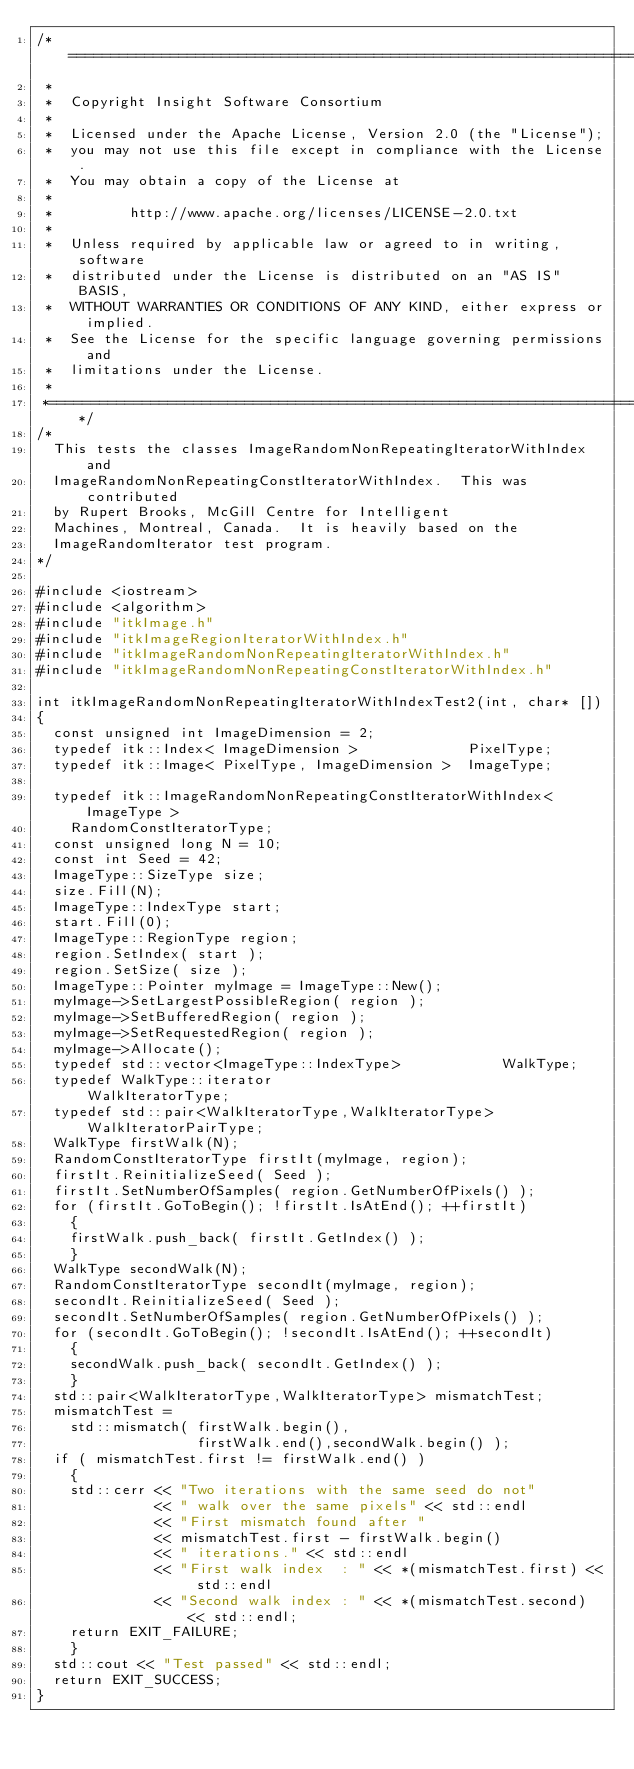<code> <loc_0><loc_0><loc_500><loc_500><_C++_>/*=========================================================================
 *
 *  Copyright Insight Software Consortium
 *
 *  Licensed under the Apache License, Version 2.0 (the "License");
 *  you may not use this file except in compliance with the License.
 *  You may obtain a copy of the License at
 *
 *         http://www.apache.org/licenses/LICENSE-2.0.txt
 *
 *  Unless required by applicable law or agreed to in writing, software
 *  distributed under the License is distributed on an "AS IS" BASIS,
 *  WITHOUT WARRANTIES OR CONDITIONS OF ANY KIND, either express or implied.
 *  See the License for the specific language governing permissions and
 *  limitations under the License.
 *
 *=========================================================================*/
/*
  This tests the classes ImageRandomNonRepeatingIteratorWithIndex and
  ImageRandomNonRepeatingConstIteratorWithIndex.  This was contributed
  by Rupert Brooks, McGill Centre for Intelligent
  Machines, Montreal, Canada.  It is heavily based on the
  ImageRandomIterator test program.
*/

#include <iostream>
#include <algorithm>
#include "itkImage.h"
#include "itkImageRegionIteratorWithIndex.h"
#include "itkImageRandomNonRepeatingIteratorWithIndex.h"
#include "itkImageRandomNonRepeatingConstIteratorWithIndex.h"

int itkImageRandomNonRepeatingIteratorWithIndexTest2(int, char* [])
{
  const unsigned int ImageDimension = 2;
  typedef itk::Index< ImageDimension >             PixelType;
  typedef itk::Image< PixelType, ImageDimension >  ImageType;

  typedef itk::ImageRandomNonRepeatingConstIteratorWithIndex< ImageType >
    RandomConstIteratorType;
  const unsigned long N = 10;
  const int Seed = 42;
  ImageType::SizeType size;
  size.Fill(N);
  ImageType::IndexType start;
  start.Fill(0);
  ImageType::RegionType region;
  region.SetIndex( start );
  region.SetSize( size );
  ImageType::Pointer myImage = ImageType::New();
  myImage->SetLargestPossibleRegion( region );
  myImage->SetBufferedRegion( region );
  myImage->SetRequestedRegion( region );
  myImage->Allocate();
  typedef std::vector<ImageType::IndexType>            WalkType;
  typedef WalkType::iterator                           WalkIteratorType;
  typedef std::pair<WalkIteratorType,WalkIteratorType> WalkIteratorPairType;
  WalkType firstWalk(N);
  RandomConstIteratorType firstIt(myImage, region);
  firstIt.ReinitializeSeed( Seed );
  firstIt.SetNumberOfSamples( region.GetNumberOfPixels() );
  for (firstIt.GoToBegin(); !firstIt.IsAtEnd(); ++firstIt)
    {
    firstWalk.push_back( firstIt.GetIndex() );
    }
  WalkType secondWalk(N);
  RandomConstIteratorType secondIt(myImage, region);
  secondIt.ReinitializeSeed( Seed );
  secondIt.SetNumberOfSamples( region.GetNumberOfPixels() );
  for (secondIt.GoToBegin(); !secondIt.IsAtEnd(); ++secondIt)
    {
    secondWalk.push_back( secondIt.GetIndex() );
    }
  std::pair<WalkIteratorType,WalkIteratorType> mismatchTest;
  mismatchTest =
    std::mismatch( firstWalk.begin(),
                   firstWalk.end(),secondWalk.begin() );
  if ( mismatchTest.first != firstWalk.end() )
    {
    std::cerr << "Two iterations with the same seed do not"
              << " walk over the same pixels" << std::endl
              << "First mismatch found after "
              << mismatchTest.first - firstWalk.begin()
              << " iterations." << std::endl
              << "First walk index  : " << *(mismatchTest.first) << std::endl
              << "Second walk index : " << *(mismatchTest.second) << std::endl;
    return EXIT_FAILURE;
    }
  std::cout << "Test passed" << std::endl;
  return EXIT_SUCCESS;
}
</code> 